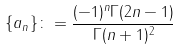Convert formula to latex. <formula><loc_0><loc_0><loc_500><loc_500>\{ a _ { n } \} \colon = \frac { ( - 1 ) ^ { n } \Gamma ( 2 n - 1 ) } { \Gamma ( n + 1 ) ^ { 2 } }</formula> 